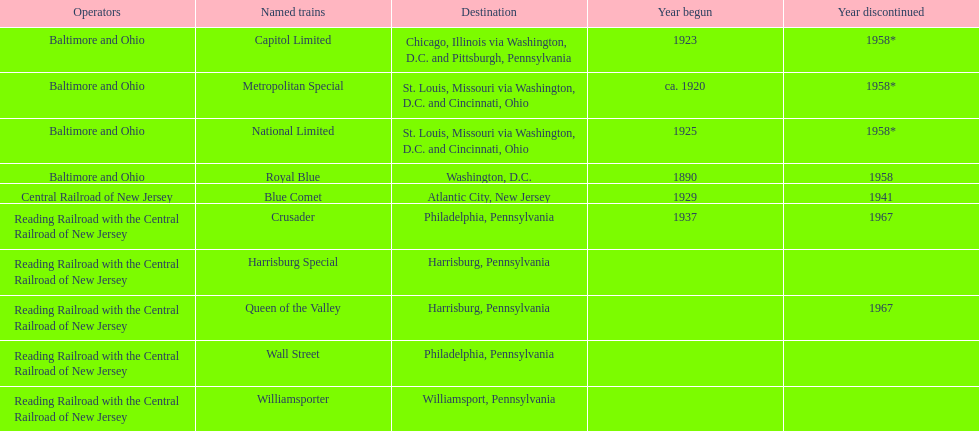Which train initiated its service as the first one? Royal Blue. 